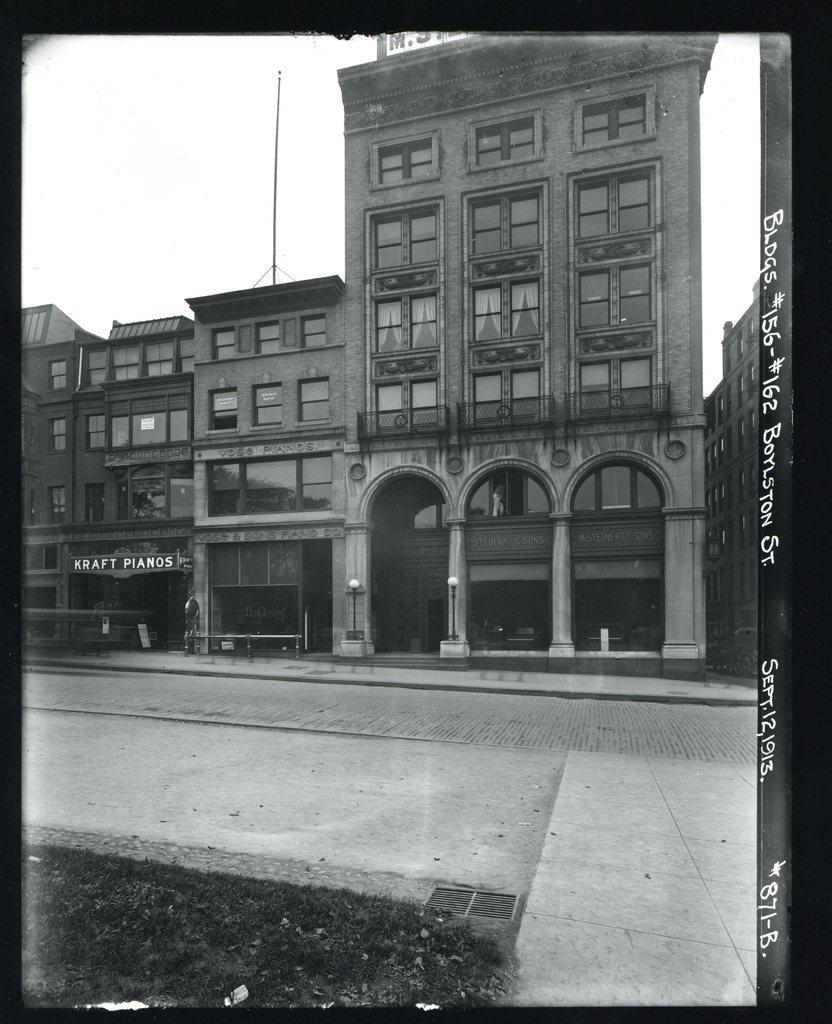Please provide a concise description of this image. In this image we can see some buildings and at the top of the image there is clear sky. 